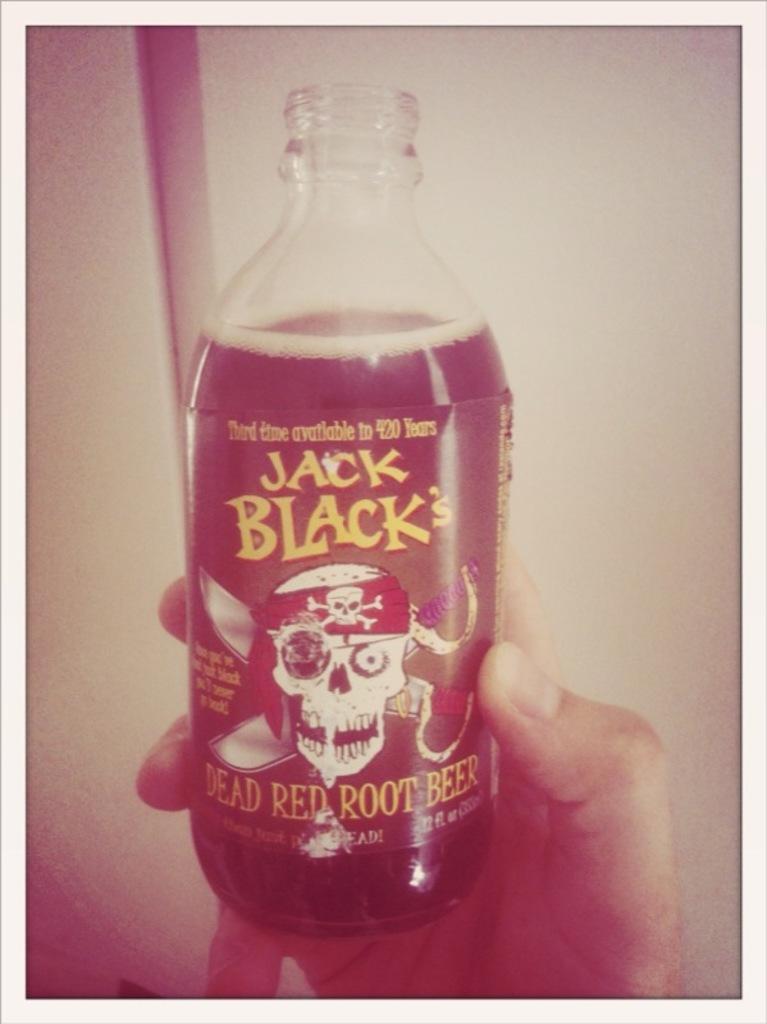What is the brand name on the can?
Your answer should be compact. Jack black. What drink is in this bottle?
Make the answer very short. Root beer. 